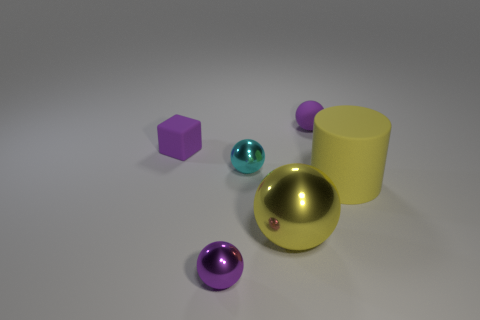Subtract all purple matte balls. How many balls are left? 3 Add 4 large shiny things. How many objects exist? 10 Subtract all purple spheres. How many spheres are left? 2 Subtract 0 green spheres. How many objects are left? 6 Subtract all cylinders. How many objects are left? 5 Subtract 1 blocks. How many blocks are left? 0 Subtract all blue balls. Subtract all red blocks. How many balls are left? 4 Subtract all brown cubes. How many yellow balls are left? 1 Subtract all large gray matte blocks. Subtract all yellow metallic balls. How many objects are left? 5 Add 1 yellow cylinders. How many yellow cylinders are left? 2 